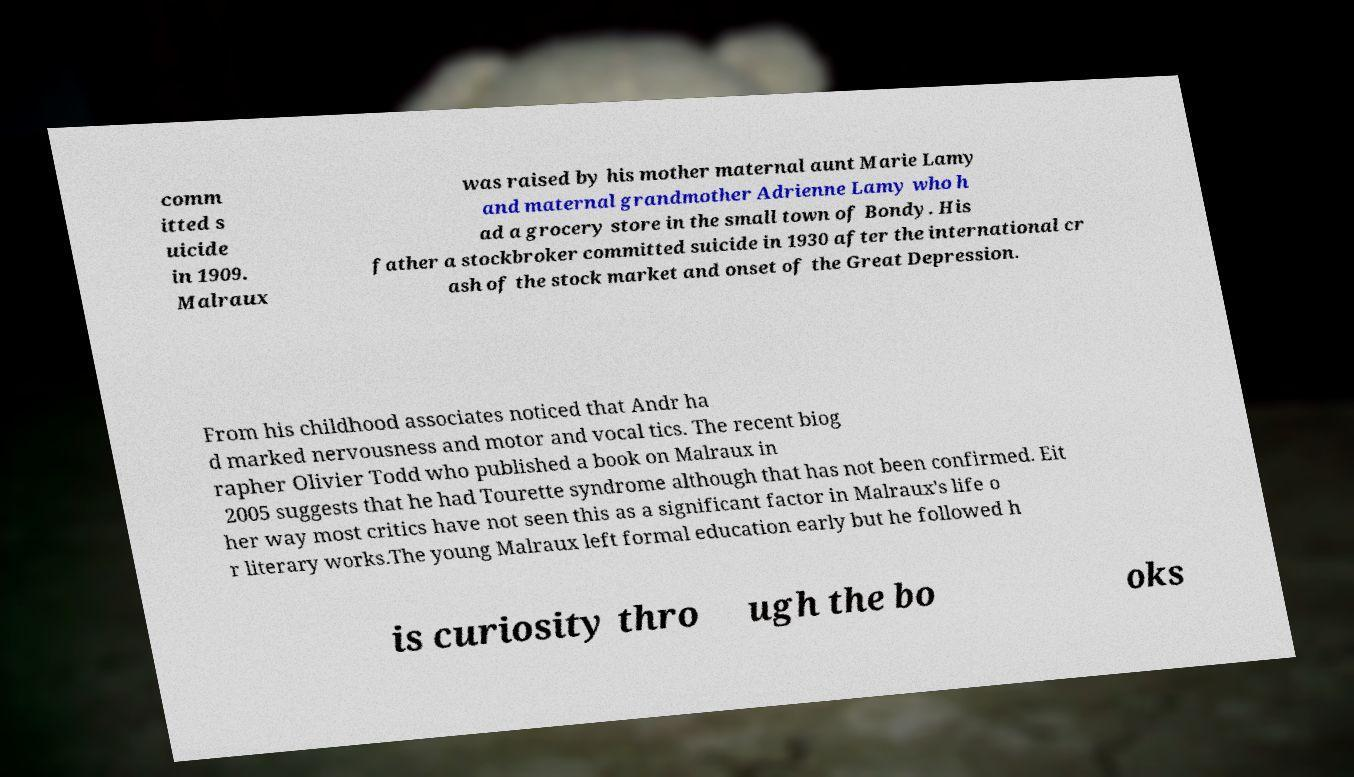For documentation purposes, I need the text within this image transcribed. Could you provide that? comm itted s uicide in 1909. Malraux was raised by his mother maternal aunt Marie Lamy and maternal grandmother Adrienne Lamy who h ad a grocery store in the small town of Bondy. His father a stockbroker committed suicide in 1930 after the international cr ash of the stock market and onset of the Great Depression. From his childhood associates noticed that Andr ha d marked nervousness and motor and vocal tics. The recent biog rapher Olivier Todd who published a book on Malraux in 2005 suggests that he had Tourette syndrome although that has not been confirmed. Eit her way most critics have not seen this as a significant factor in Malraux's life o r literary works.The young Malraux left formal education early but he followed h is curiosity thro ugh the bo oks 